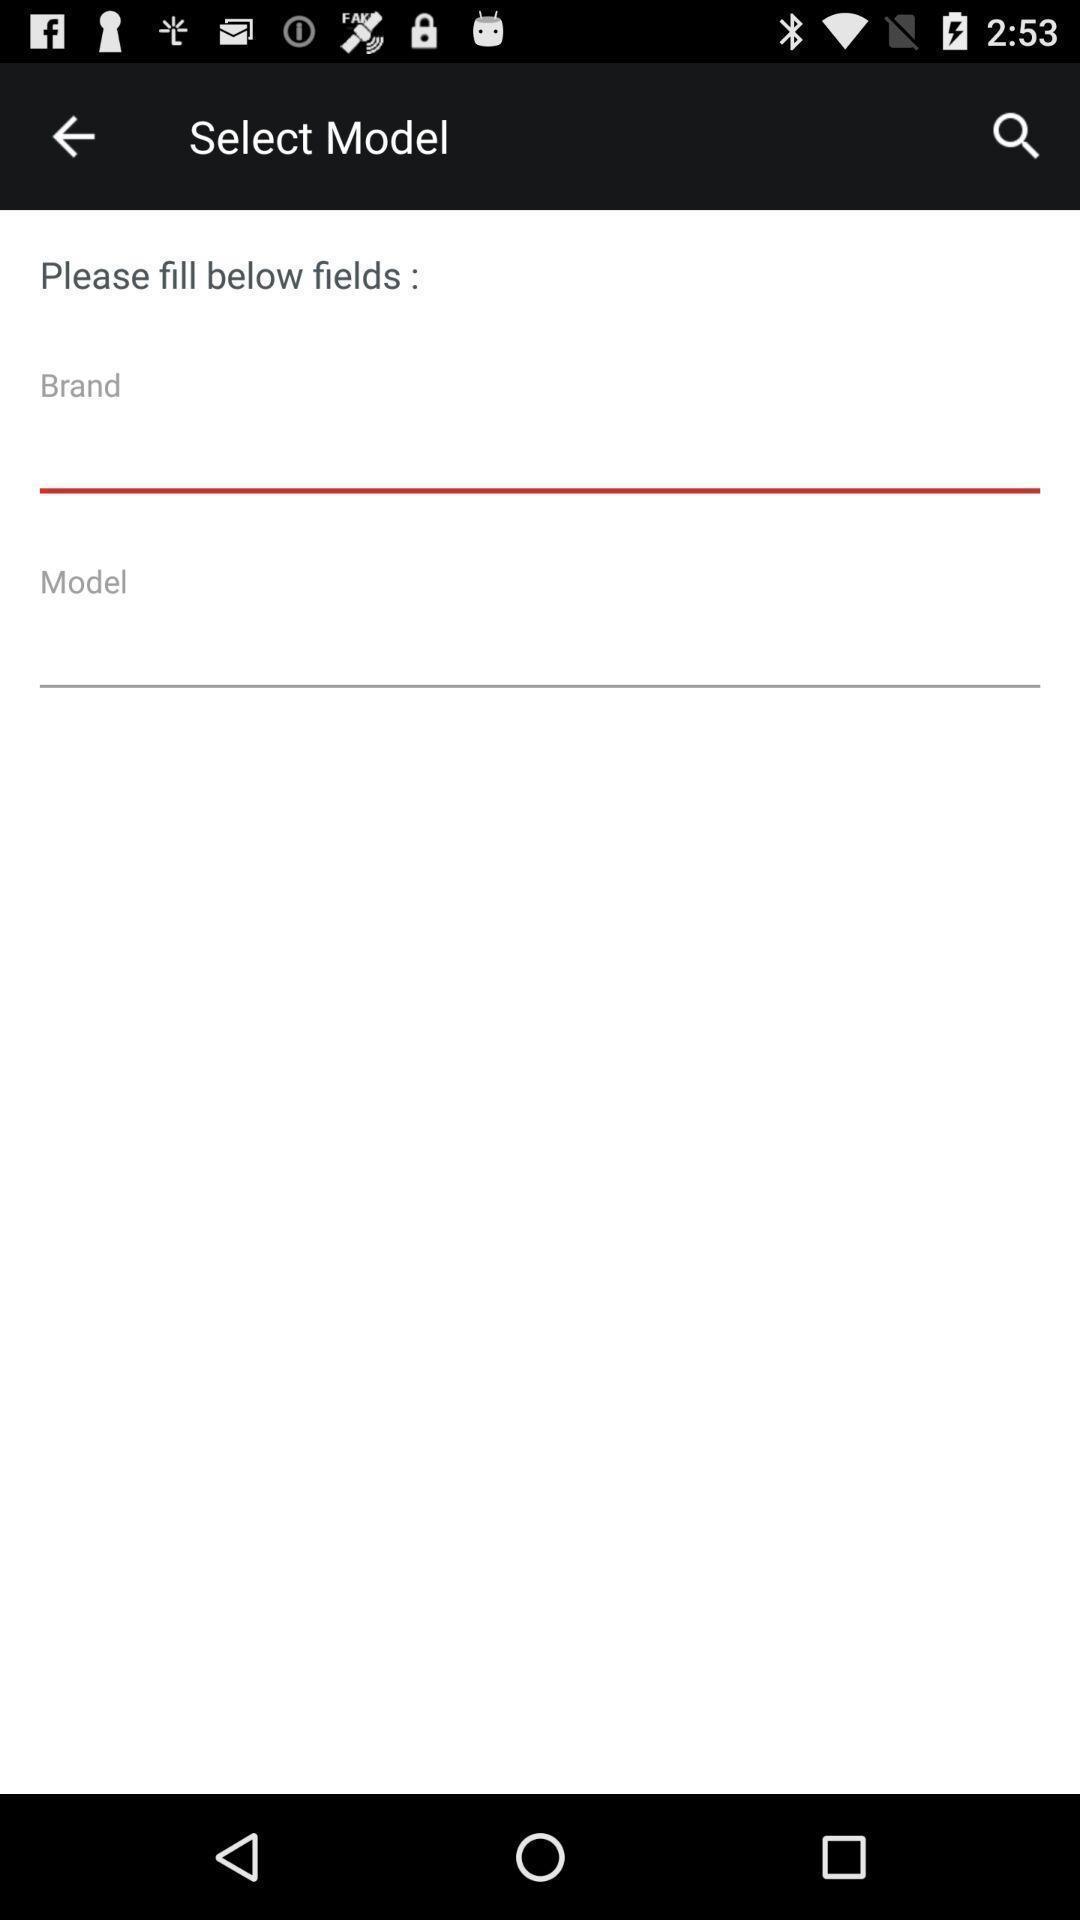Give me a summary of this screen capture. Screen showing fill below fields. 